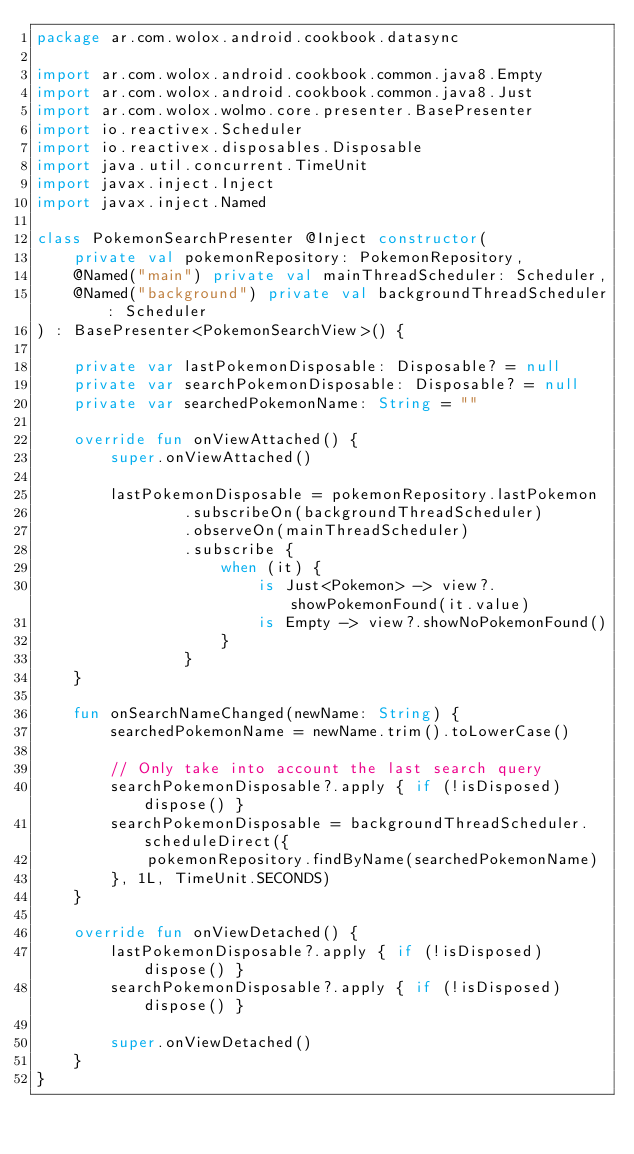Convert code to text. <code><loc_0><loc_0><loc_500><loc_500><_Kotlin_>package ar.com.wolox.android.cookbook.datasync

import ar.com.wolox.android.cookbook.common.java8.Empty
import ar.com.wolox.android.cookbook.common.java8.Just
import ar.com.wolox.wolmo.core.presenter.BasePresenter
import io.reactivex.Scheduler
import io.reactivex.disposables.Disposable
import java.util.concurrent.TimeUnit
import javax.inject.Inject
import javax.inject.Named

class PokemonSearchPresenter @Inject constructor(
    private val pokemonRepository: PokemonRepository,
    @Named("main") private val mainThreadScheduler: Scheduler,
    @Named("background") private val backgroundThreadScheduler: Scheduler
) : BasePresenter<PokemonSearchView>() {

    private var lastPokemonDisposable: Disposable? = null
    private var searchPokemonDisposable: Disposable? = null
    private var searchedPokemonName: String = ""

    override fun onViewAttached() {
        super.onViewAttached()

        lastPokemonDisposable = pokemonRepository.lastPokemon
                .subscribeOn(backgroundThreadScheduler)
                .observeOn(mainThreadScheduler)
                .subscribe {
                    when (it) {
                        is Just<Pokemon> -> view?.showPokemonFound(it.value)
                        is Empty -> view?.showNoPokemonFound()
                    }
                }
    }

    fun onSearchNameChanged(newName: String) {
        searchedPokemonName = newName.trim().toLowerCase()

        // Only take into account the last search query
        searchPokemonDisposable?.apply { if (!isDisposed) dispose() }
        searchPokemonDisposable = backgroundThreadScheduler.scheduleDirect({
            pokemonRepository.findByName(searchedPokemonName)
        }, 1L, TimeUnit.SECONDS)
    }

    override fun onViewDetached() {
        lastPokemonDisposable?.apply { if (!isDisposed) dispose() }
        searchPokemonDisposable?.apply { if (!isDisposed) dispose() }

        super.onViewDetached()
    }
}</code> 